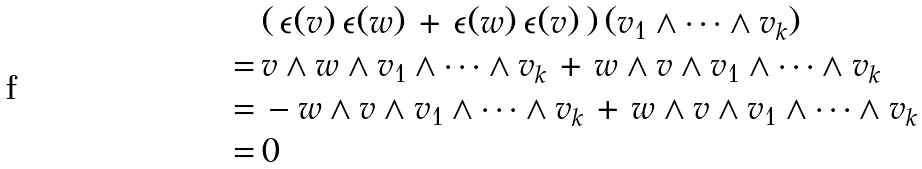Convert formula to latex. <formula><loc_0><loc_0><loc_500><loc_500>& ( \, \epsilon ( v ) \, \epsilon ( w ) \, + \, \epsilon ( w ) \, \epsilon ( v ) \, ) \, ( v _ { 1 } \wedge \dots \wedge v _ { k } ) \\ = \, & v \wedge w \wedge v _ { 1 } \wedge \dots \wedge v _ { k } \, + \, w \wedge v \wedge v _ { 1 } \wedge \dots \wedge v _ { k } \\ = \, & - w \wedge v \wedge v _ { 1 } \wedge \dots \wedge v _ { k } \, + \, w \wedge v \wedge v _ { 1 } \wedge \dots \wedge v _ { k } \\ = \, & 0</formula> 